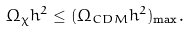Convert formula to latex. <formula><loc_0><loc_0><loc_500><loc_500>\Omega _ { \chi } h ^ { 2 } \leq ( \Omega _ { C D M } h ^ { 2 } ) _ { \max } .</formula> 